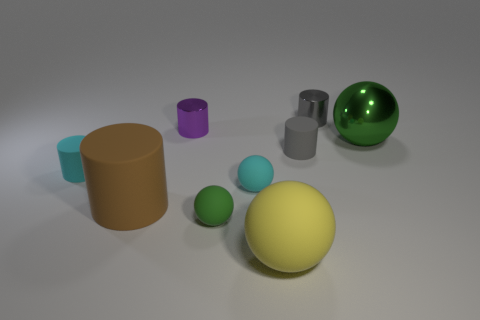What is the material of the tiny ball behind the green rubber thing?
Your answer should be very brief. Rubber. Is the small gray metal thing the same shape as the brown rubber thing?
Your response must be concise. Yes. How many other things are the same shape as the big brown object?
Ensure brevity in your answer.  4. There is a tiny metal cylinder right of the tiny gray matte object; what is its color?
Offer a very short reply. Gray. Is the green rubber thing the same size as the green metal object?
Make the answer very short. No. The cyan thing left of the green sphere to the left of the big rubber sphere is made of what material?
Your answer should be very brief. Rubber. What number of other balls have the same color as the large metal sphere?
Give a very brief answer. 1. Is there anything else that is made of the same material as the cyan ball?
Your answer should be compact. Yes. Is the number of large brown objects that are right of the tiny cyan ball less than the number of brown matte things?
Give a very brief answer. Yes. There is a tiny metallic cylinder in front of the small cylinder behind the purple metal cylinder; what is its color?
Keep it short and to the point. Purple. 